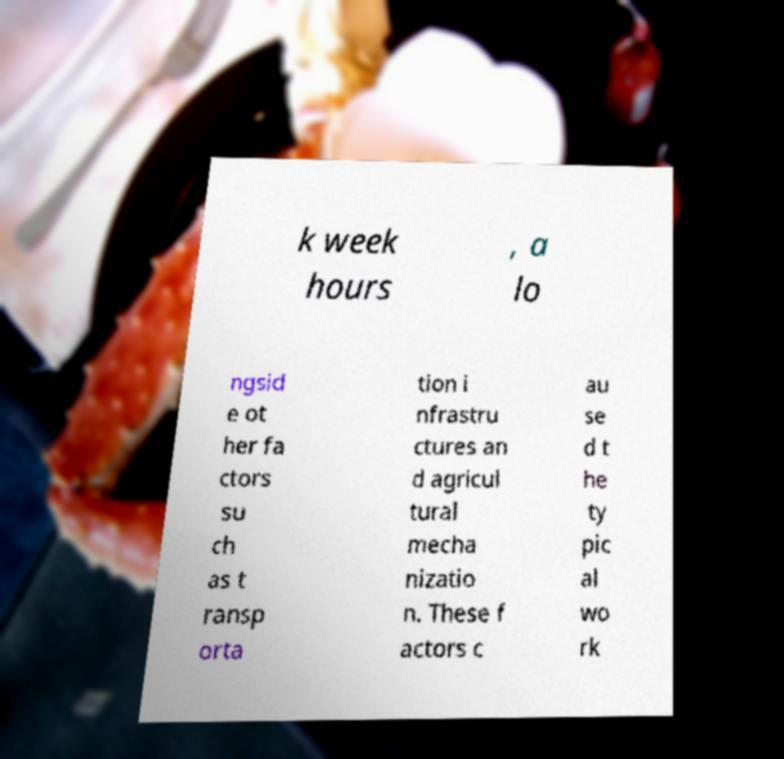Could you extract and type out the text from this image? k week hours , a lo ngsid e ot her fa ctors su ch as t ransp orta tion i nfrastru ctures an d agricul tural mecha nizatio n. These f actors c au se d t he ty pic al wo rk 